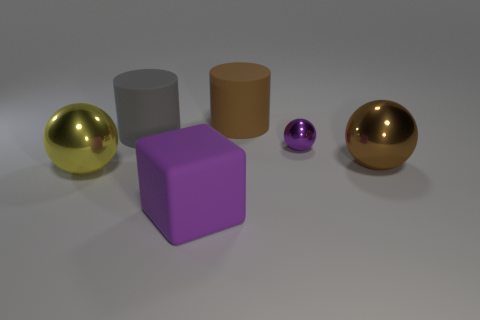Subtract all brown cylinders. How many cylinders are left? 1 Subtract all small shiny spheres. How many spheres are left? 2 Subtract 1 yellow spheres. How many objects are left? 5 Subtract all cylinders. How many objects are left? 4 Subtract 2 cylinders. How many cylinders are left? 0 Subtract all yellow cylinders. Subtract all red spheres. How many cylinders are left? 2 Subtract all green cylinders. How many purple balls are left? 1 Subtract all small shiny balls. Subtract all yellow shiny things. How many objects are left? 4 Add 4 large purple cubes. How many large purple cubes are left? 5 Add 2 yellow metallic balls. How many yellow metallic balls exist? 3 